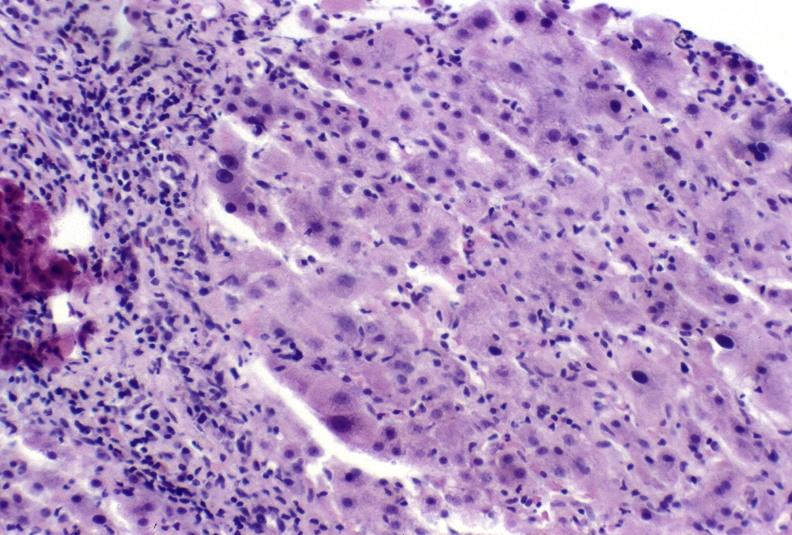s liver present?
Answer the question using a single word or phrase. Yes 